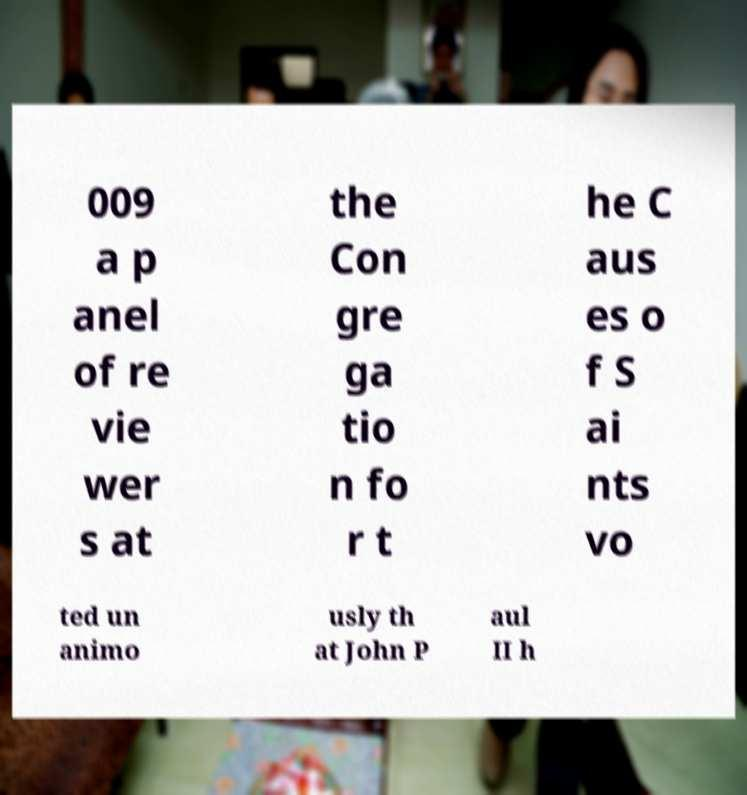Could you assist in decoding the text presented in this image and type it out clearly? 009 a p anel of re vie wer s at the Con gre ga tio n fo r t he C aus es o f S ai nts vo ted un animo usly th at John P aul II h 